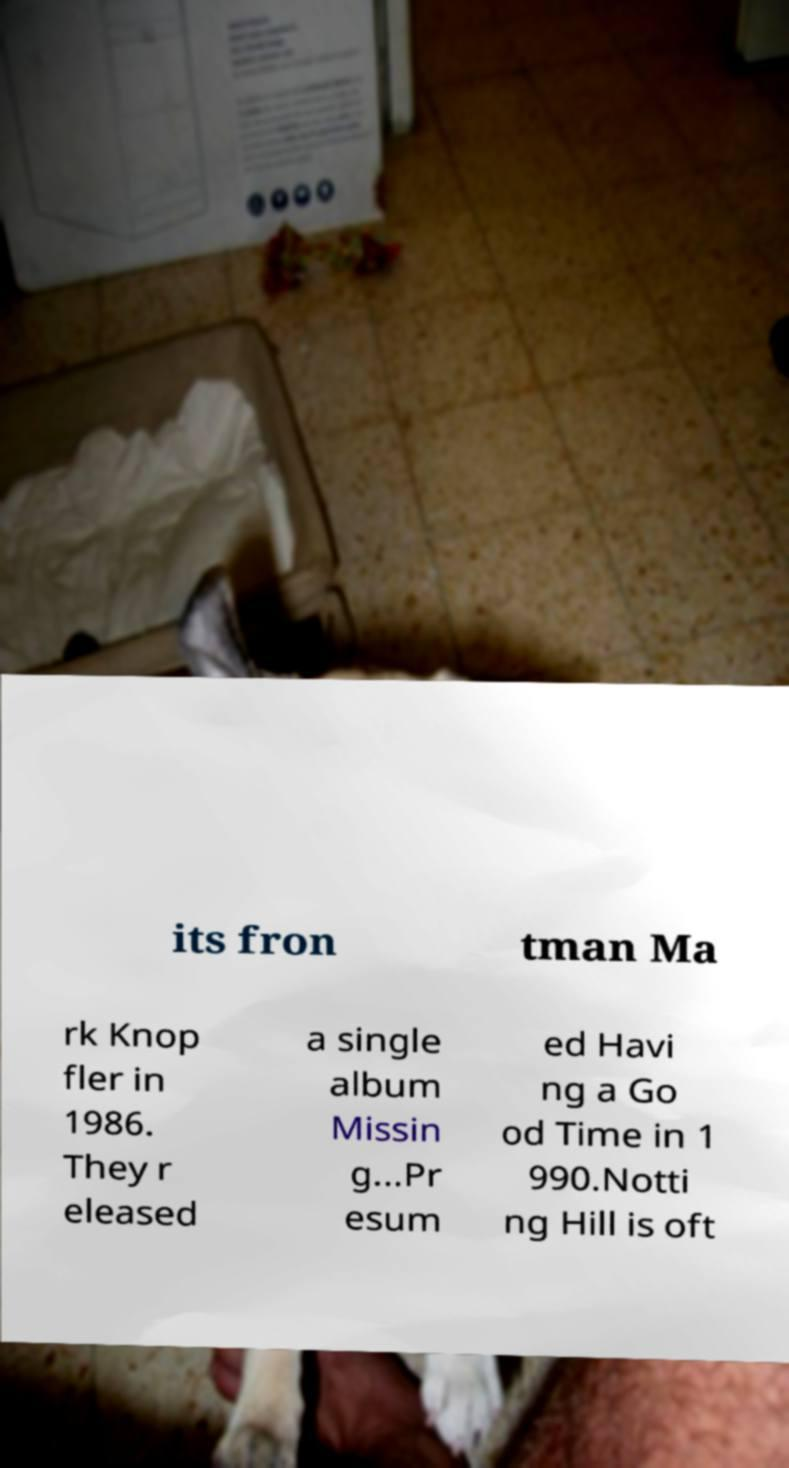Please read and relay the text visible in this image. What does it say? its fron tman Ma rk Knop fler in 1986. They r eleased a single album Missin g...Pr esum ed Havi ng a Go od Time in 1 990.Notti ng Hill is oft 